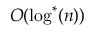Convert formula to latex. <formula><loc_0><loc_0><loc_500><loc_500>O ( \log ^ { * } ( n ) )</formula> 